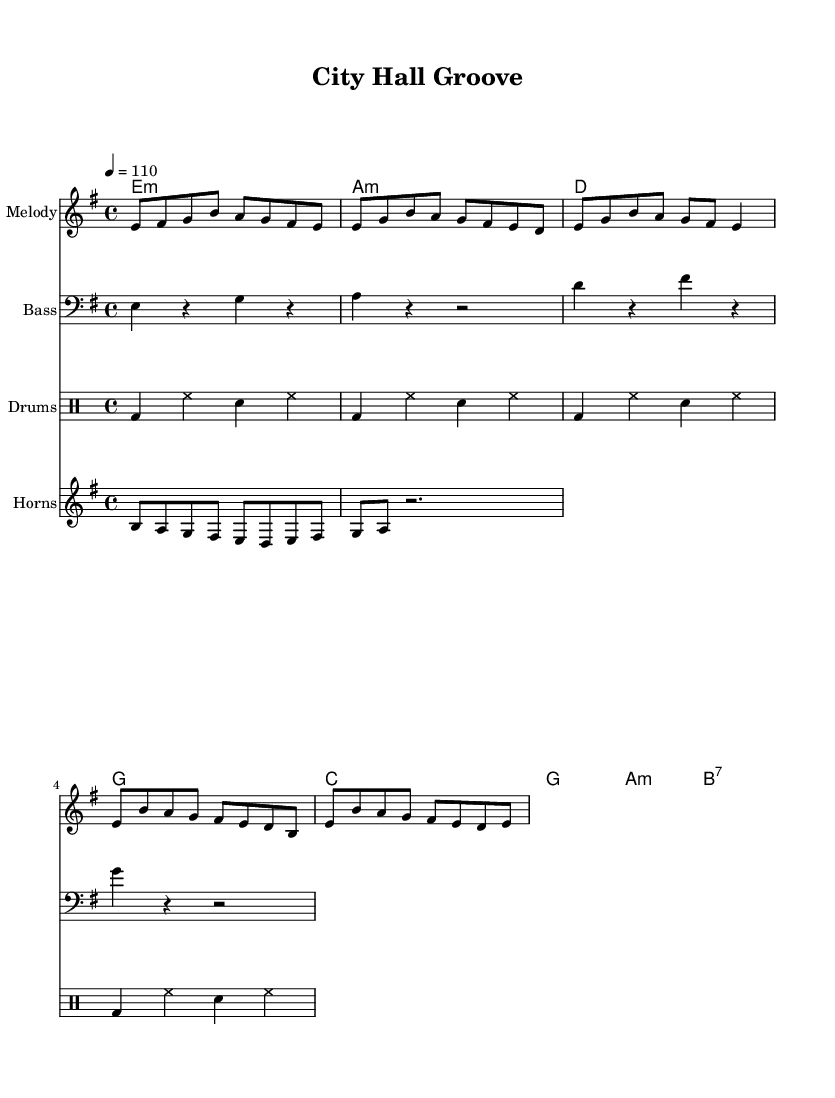What is the key signature of this music? The key signature indicates that the music is in E minor, which has one sharp (F#).
Answer: E minor What is the time signature of this music? The time signature is shown at the beginning of the piece, which indicates the music is in a 4/4 time signature, meaning there are four beats in each measure.
Answer: 4/4 What is the tempo of this music? The tempo marking is at the beginning of the piece, stating that the music should be played at a speed of 110 beats per minute.
Answer: 110 What type of bass line is used in this piece? The bass line is notated in a separate staff and is generally consistent with the root notes of the chords, suggesting a foundational funk style often characterized by syncopation and rhythm.
Answer: Root-based How many measures are there in the chorus section? By analyzing the measures in the chorus part of the sheet music, we can count that there are four measures in total.
Answer: 4 What is a hallmark of funk music as seen in this piece? The music features elements typical of funk, including a strong emphasis on the downbeat in the rhythm section and use of syncopated horn riffs, which are integral to the genre's sound.
Answer: Syncopation 